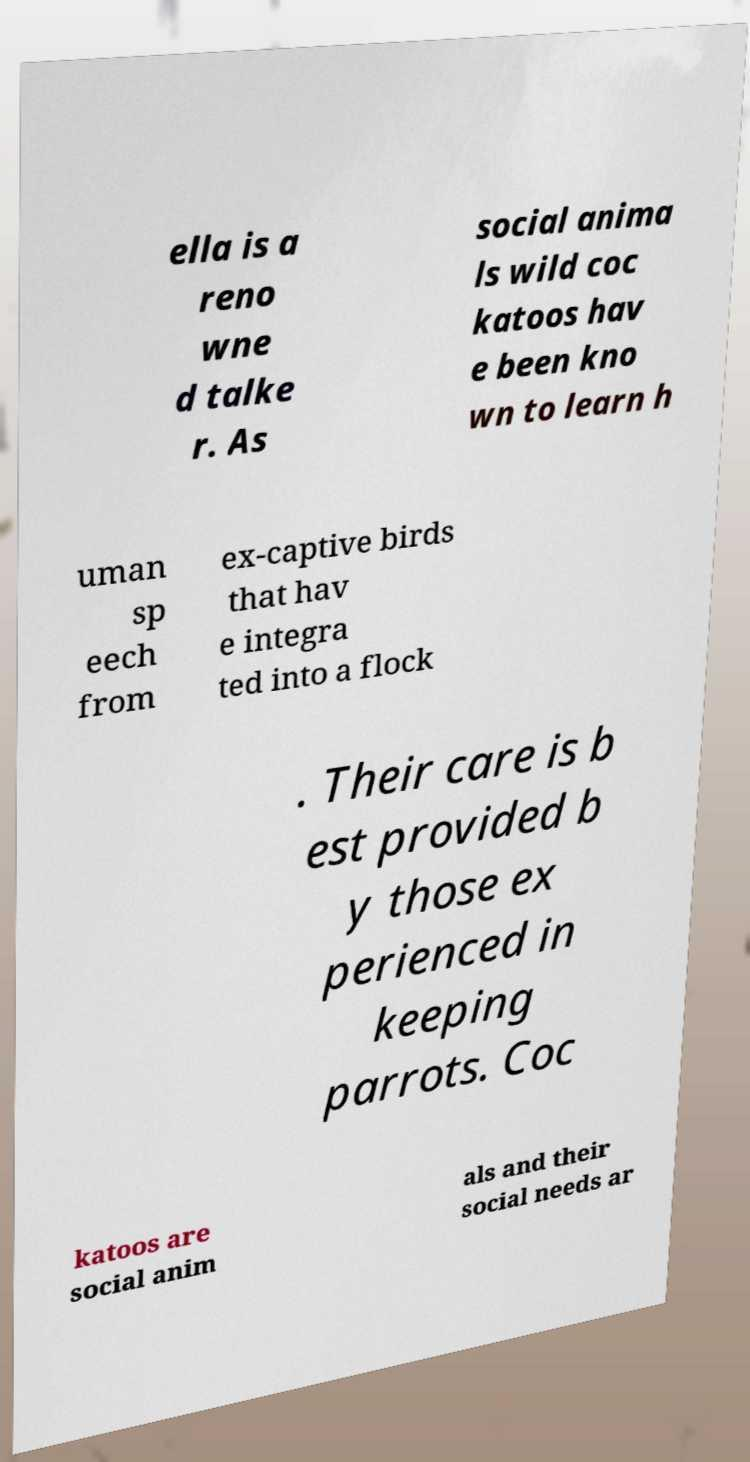There's text embedded in this image that I need extracted. Can you transcribe it verbatim? ella is a reno wne d talke r. As social anima ls wild coc katoos hav e been kno wn to learn h uman sp eech from ex-captive birds that hav e integra ted into a flock . Their care is b est provided b y those ex perienced in keeping parrots. Coc katoos are social anim als and their social needs ar 